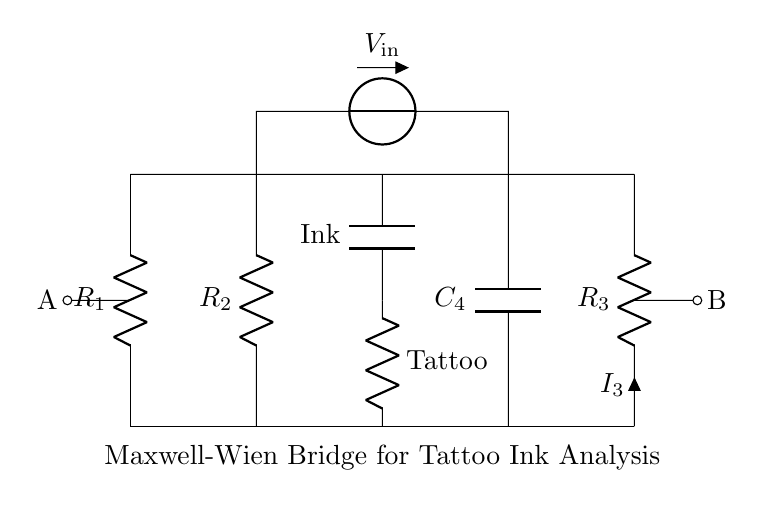What is the resistance of R1? The circuit diagram does not specify numerical values for the components; thus, I cannot answer that without additional information.
Answer: Not specified What component is labeled 'Tattoo'? The component labeled 'Tattoo' is the resistor R_x, which represents the electrical properties of the tattoo.
Answer: R_x What is the function of C_x in the circuit? C_x is a capacitor connected in parallel with the resistor R_x, which suggests it is used to analyze the capacitive properties of the tattoo ink.
Answer: Capacitive analysis What is the input voltage symbol in this circuit? The input voltage is represented by the symbol V_in, which is positioned between resistors R2 and C4, indicating where the voltage is applied.
Answer: V_in What is the type of bridge represented in this circuit? The type of bridge shown in the circuit is a Maxwell-Wien bridge, which is specifically used for measuring the parameters of capacitors in AC circuits.
Answer: Maxwell-Wien bridge What connections exist between points A and B? Points A and B are connected by the resistors and the output current I3, forming part of the bridge circuit, indicating that the voltage across component R3 relates to R_x's measurement.
Answer: Resistors and output current What is C4’s role in the circuit? C4 is a capacitor that likely helps to stabilize the circuit and allows for capacitance measurement in conjunction with R3, which together aid in determining the electrical properties of tattoo inks.
Answer: Stabilization and measurement 